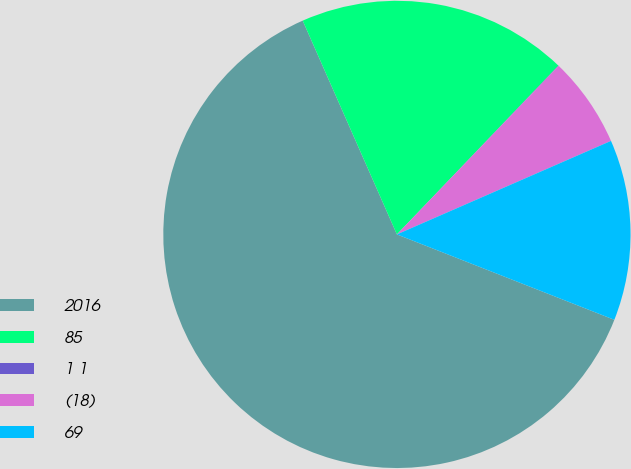Convert chart to OTSL. <chart><loc_0><loc_0><loc_500><loc_500><pie_chart><fcel>2016<fcel>85<fcel>1 1<fcel>(18)<fcel>69<nl><fcel>62.43%<fcel>18.75%<fcel>0.03%<fcel>6.27%<fcel>12.51%<nl></chart> 